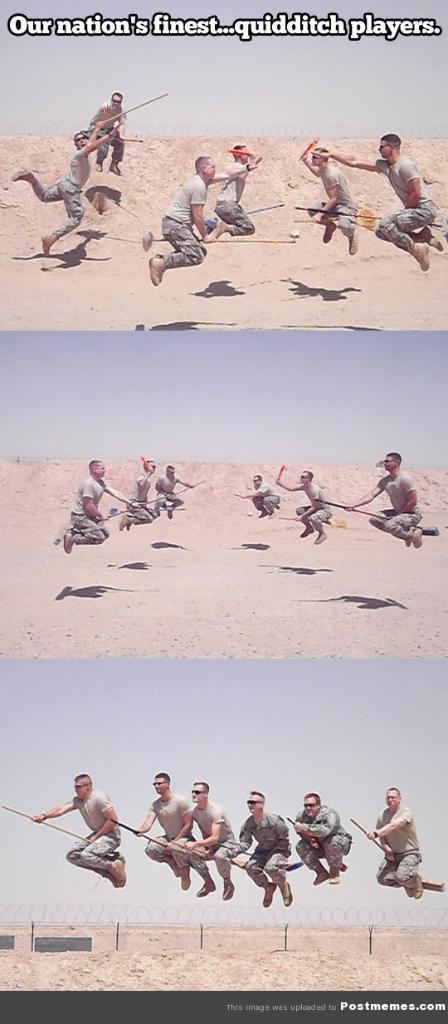<image>
Summarize the visual content of the image. Group of army men in the desert playing quidditch. 